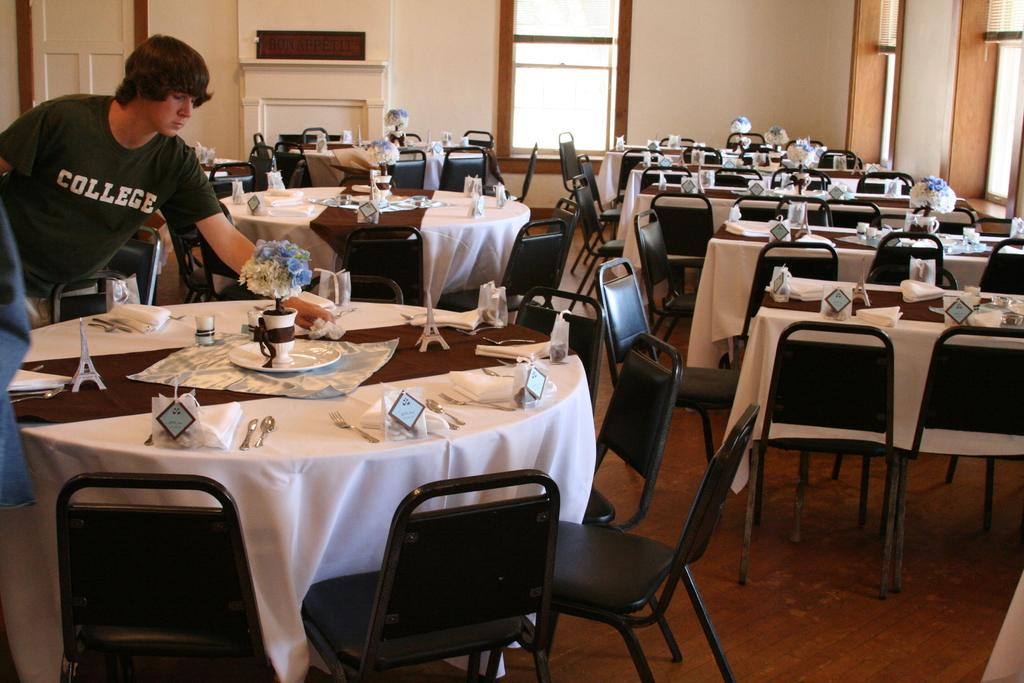What type of furniture is present in the room? There are tables and chairs in the room. How are the tables and chairs arranged in the room? The tables and chairs are arranged for dining. Is there anyone present in the room? Yes, there is a man standing in the room. What type of fork is the man using to divide the lead in the image? There is no fork, division, or lead present in the image. 